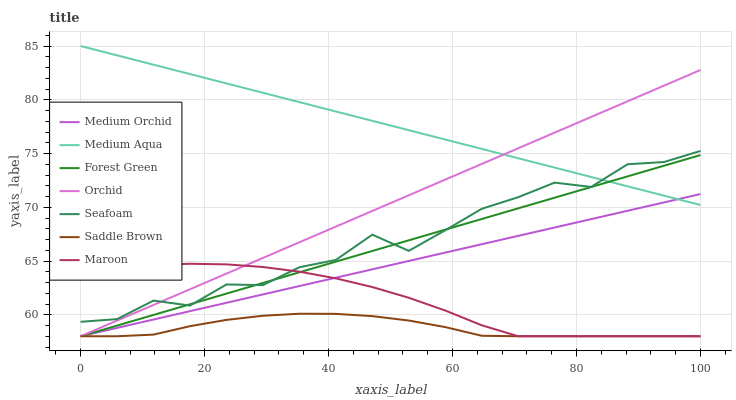Does Saddle Brown have the minimum area under the curve?
Answer yes or no. Yes. Does Medium Aqua have the maximum area under the curve?
Answer yes or no. Yes. Does Seafoam have the minimum area under the curve?
Answer yes or no. No. Does Seafoam have the maximum area under the curve?
Answer yes or no. No. Is Forest Green the smoothest?
Answer yes or no. Yes. Is Seafoam the roughest?
Answer yes or no. Yes. Is Maroon the smoothest?
Answer yes or no. No. Is Maroon the roughest?
Answer yes or no. No. Does Medium Orchid have the lowest value?
Answer yes or no. Yes. Does Seafoam have the lowest value?
Answer yes or no. No. Does Medium Aqua have the highest value?
Answer yes or no. Yes. Does Seafoam have the highest value?
Answer yes or no. No. Is Saddle Brown less than Medium Aqua?
Answer yes or no. Yes. Is Seafoam greater than Medium Orchid?
Answer yes or no. Yes. Does Medium Aqua intersect Medium Orchid?
Answer yes or no. Yes. Is Medium Aqua less than Medium Orchid?
Answer yes or no. No. Is Medium Aqua greater than Medium Orchid?
Answer yes or no. No. Does Saddle Brown intersect Medium Aqua?
Answer yes or no. No. 